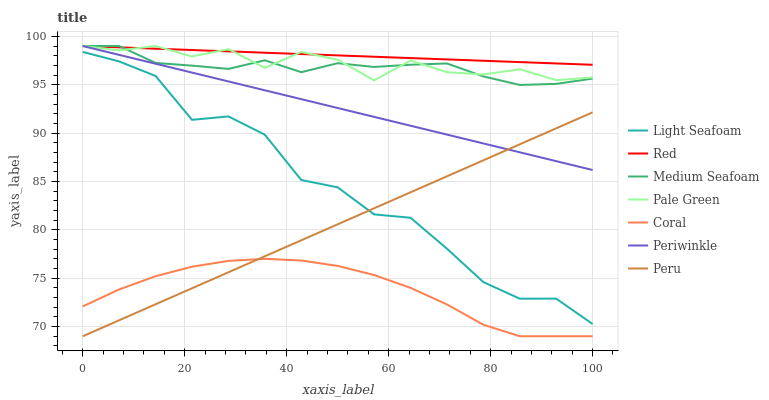Does Coral have the minimum area under the curve?
Answer yes or no. Yes. Does Red have the maximum area under the curve?
Answer yes or no. Yes. Does Pale Green have the minimum area under the curve?
Answer yes or no. No. Does Pale Green have the maximum area under the curve?
Answer yes or no. No. Is Red the smoothest?
Answer yes or no. Yes. Is Light Seafoam the roughest?
Answer yes or no. Yes. Is Pale Green the smoothest?
Answer yes or no. No. Is Pale Green the roughest?
Answer yes or no. No. Does Coral have the lowest value?
Answer yes or no. Yes. Does Pale Green have the lowest value?
Answer yes or no. No. Does Red have the highest value?
Answer yes or no. Yes. Does Peru have the highest value?
Answer yes or no. No. Is Light Seafoam less than Pale Green?
Answer yes or no. Yes. Is Red greater than Coral?
Answer yes or no. Yes. Does Red intersect Medium Seafoam?
Answer yes or no. Yes. Is Red less than Medium Seafoam?
Answer yes or no. No. Is Red greater than Medium Seafoam?
Answer yes or no. No. Does Light Seafoam intersect Pale Green?
Answer yes or no. No. 